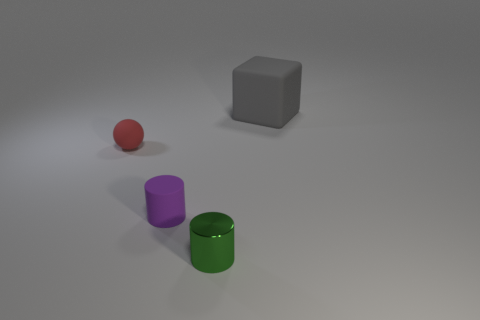Add 1 large objects. How many objects exist? 5 Subtract all balls. How many objects are left? 3 Add 4 tiny red matte spheres. How many tiny red matte spheres are left? 5 Add 2 green objects. How many green objects exist? 3 Subtract 0 cyan cubes. How many objects are left? 4 Subtract all big green matte cubes. Subtract all cylinders. How many objects are left? 2 